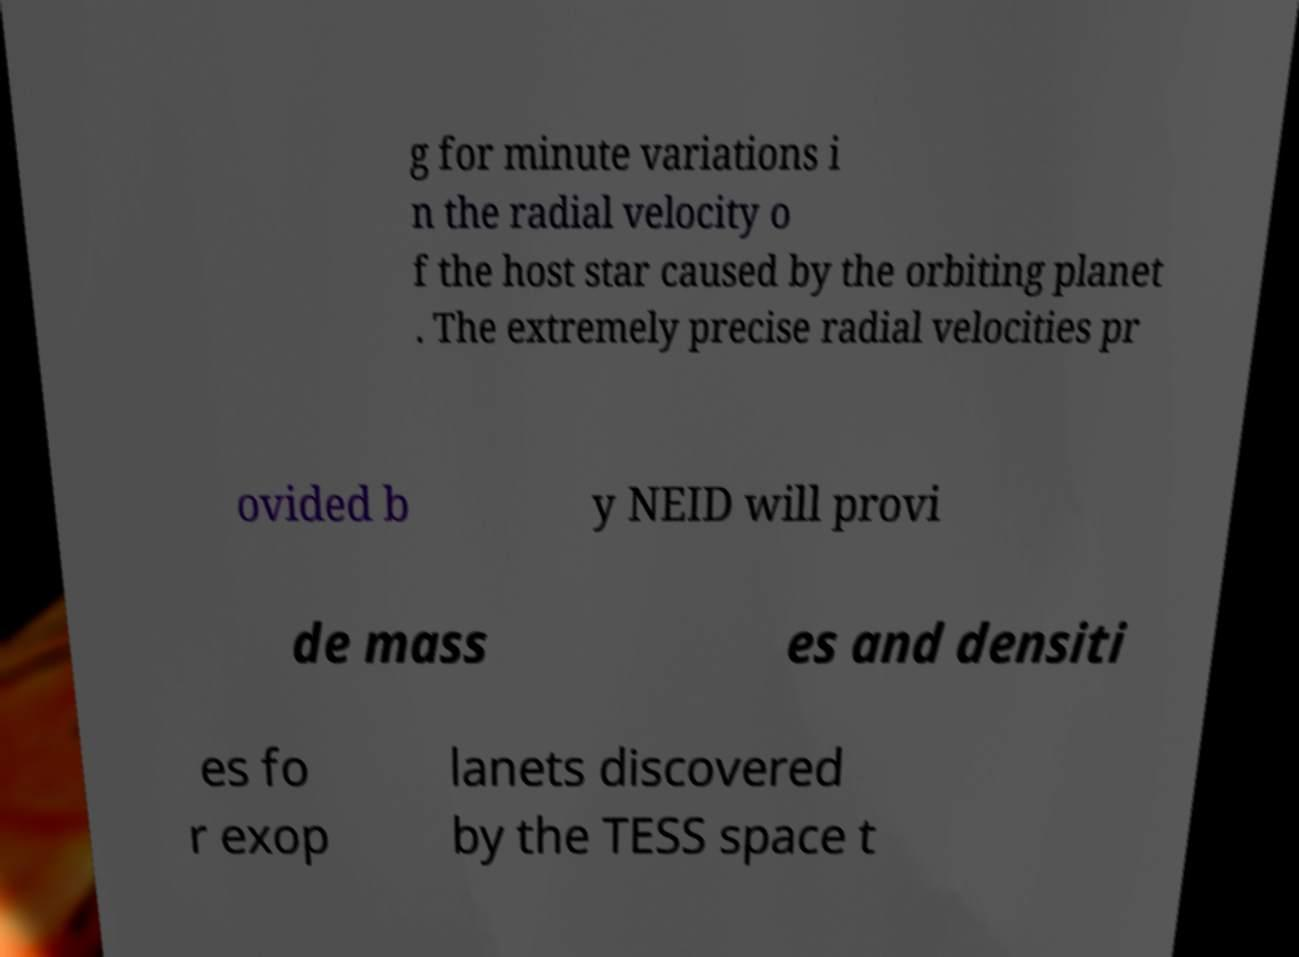Please identify and transcribe the text found in this image. g for minute variations i n the radial velocity o f the host star caused by the orbiting planet . The extremely precise radial velocities pr ovided b y NEID will provi de mass es and densiti es fo r exop lanets discovered by the TESS space t 